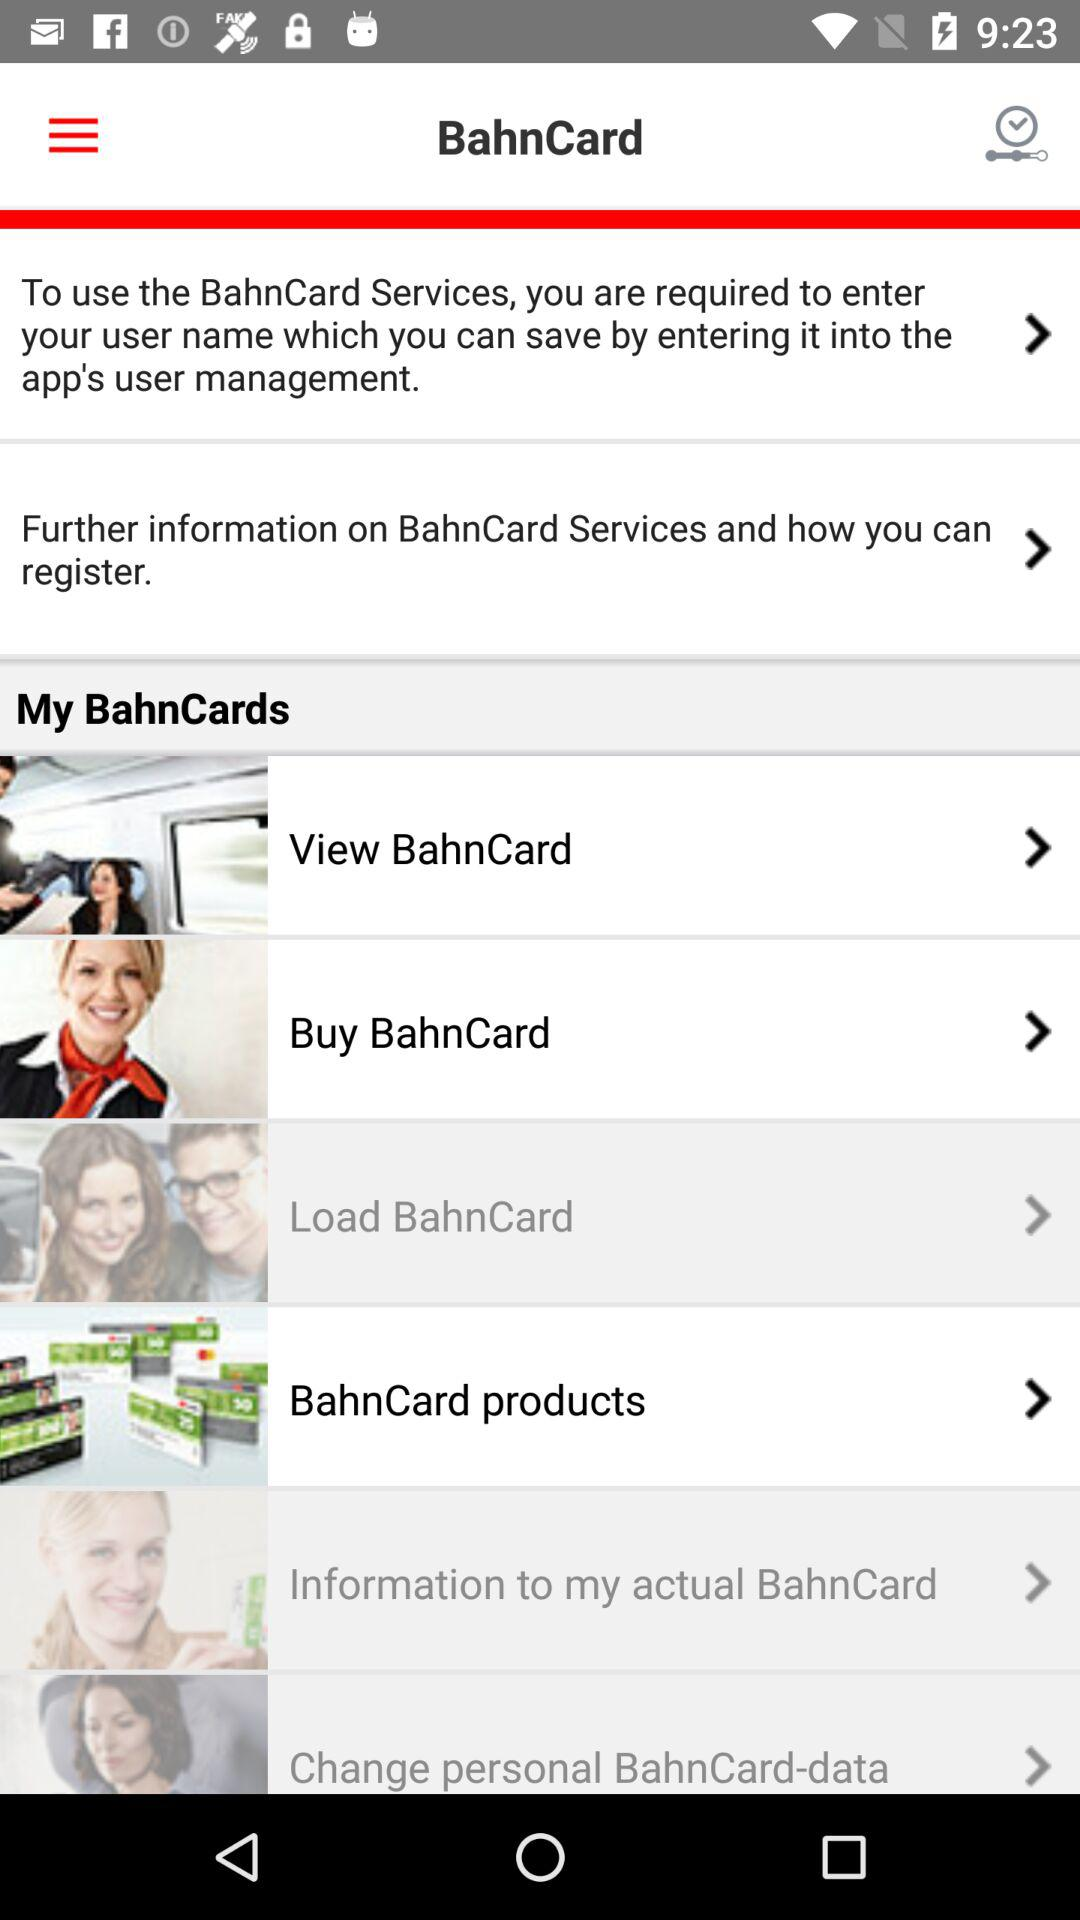What is BahnCard?
When the provided information is insufficient, respond with <no answer>. <no answer> 